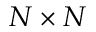<formula> <loc_0><loc_0><loc_500><loc_500>N \times N</formula> 